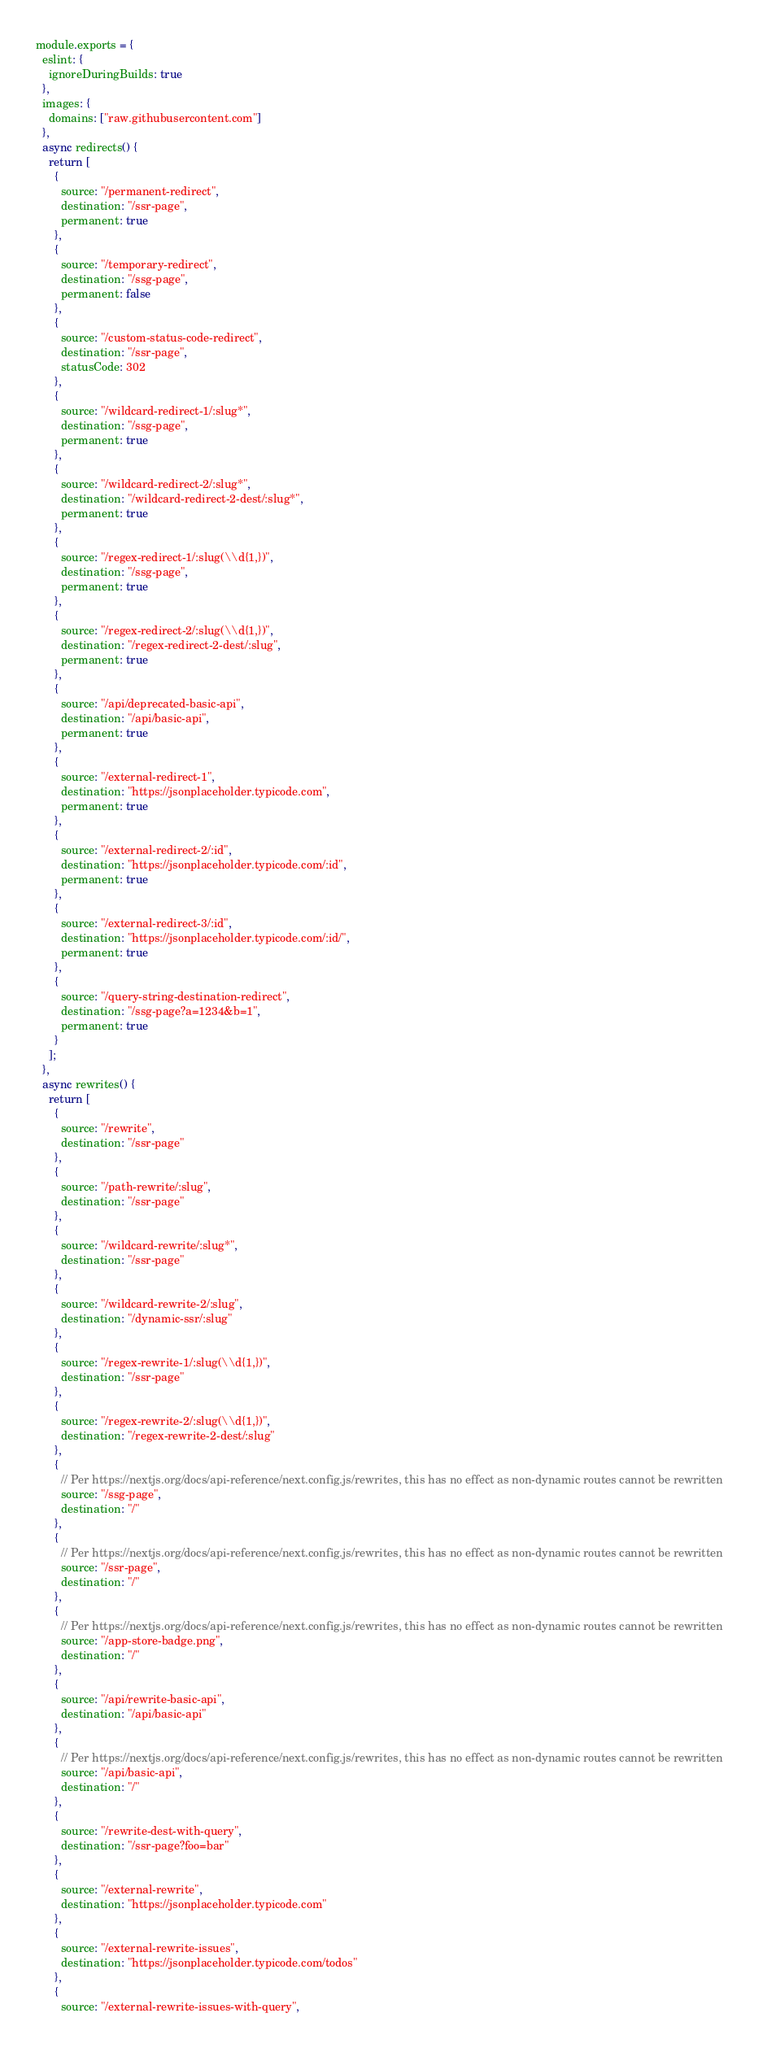<code> <loc_0><loc_0><loc_500><loc_500><_JavaScript_>module.exports = {
  eslint: {
    ignoreDuringBuilds: true
  },
  images: {
    domains: ["raw.githubusercontent.com"]
  },
  async redirects() {
    return [
      {
        source: "/permanent-redirect",
        destination: "/ssr-page",
        permanent: true
      },
      {
        source: "/temporary-redirect",
        destination: "/ssg-page",
        permanent: false
      },
      {
        source: "/custom-status-code-redirect",
        destination: "/ssr-page",
        statusCode: 302
      },
      {
        source: "/wildcard-redirect-1/:slug*",
        destination: "/ssg-page",
        permanent: true
      },
      {
        source: "/wildcard-redirect-2/:slug*",
        destination: "/wildcard-redirect-2-dest/:slug*",
        permanent: true
      },
      {
        source: "/regex-redirect-1/:slug(\\d{1,})",
        destination: "/ssg-page",
        permanent: true
      },
      {
        source: "/regex-redirect-2/:slug(\\d{1,})",
        destination: "/regex-redirect-2-dest/:slug",
        permanent: true
      },
      {
        source: "/api/deprecated-basic-api",
        destination: "/api/basic-api",
        permanent: true
      },
      {
        source: "/external-redirect-1",
        destination: "https://jsonplaceholder.typicode.com",
        permanent: true
      },
      {
        source: "/external-redirect-2/:id",
        destination: "https://jsonplaceholder.typicode.com/:id",
        permanent: true
      },
      {
        source: "/external-redirect-3/:id",
        destination: "https://jsonplaceholder.typicode.com/:id/",
        permanent: true
      },
      {
        source: "/query-string-destination-redirect",
        destination: "/ssg-page?a=1234&b=1",
        permanent: true
      }
    ];
  },
  async rewrites() {
    return [
      {
        source: "/rewrite",
        destination: "/ssr-page"
      },
      {
        source: "/path-rewrite/:slug",
        destination: "/ssr-page"
      },
      {
        source: "/wildcard-rewrite/:slug*",
        destination: "/ssr-page"
      },
      {
        source: "/wildcard-rewrite-2/:slug",
        destination: "/dynamic-ssr/:slug"
      },
      {
        source: "/regex-rewrite-1/:slug(\\d{1,})",
        destination: "/ssr-page"
      },
      {
        source: "/regex-rewrite-2/:slug(\\d{1,})",
        destination: "/regex-rewrite-2-dest/:slug"
      },
      {
        // Per https://nextjs.org/docs/api-reference/next.config.js/rewrites, this has no effect as non-dynamic routes cannot be rewritten
        source: "/ssg-page",
        destination: "/"
      },
      {
        // Per https://nextjs.org/docs/api-reference/next.config.js/rewrites, this has no effect as non-dynamic routes cannot be rewritten
        source: "/ssr-page",
        destination: "/"
      },
      {
        // Per https://nextjs.org/docs/api-reference/next.config.js/rewrites, this has no effect as non-dynamic routes cannot be rewritten
        source: "/app-store-badge.png",
        destination: "/"
      },
      {
        source: "/api/rewrite-basic-api",
        destination: "/api/basic-api"
      },
      {
        // Per https://nextjs.org/docs/api-reference/next.config.js/rewrites, this has no effect as non-dynamic routes cannot be rewritten
        source: "/api/basic-api",
        destination: "/"
      },
      {
        source: "/rewrite-dest-with-query",
        destination: "/ssr-page?foo=bar"
      },
      {
        source: "/external-rewrite",
        destination: "https://jsonplaceholder.typicode.com"
      },
      {
        source: "/external-rewrite-issues",
        destination: "https://jsonplaceholder.typicode.com/todos"
      },
      {
        source: "/external-rewrite-issues-with-query",</code> 